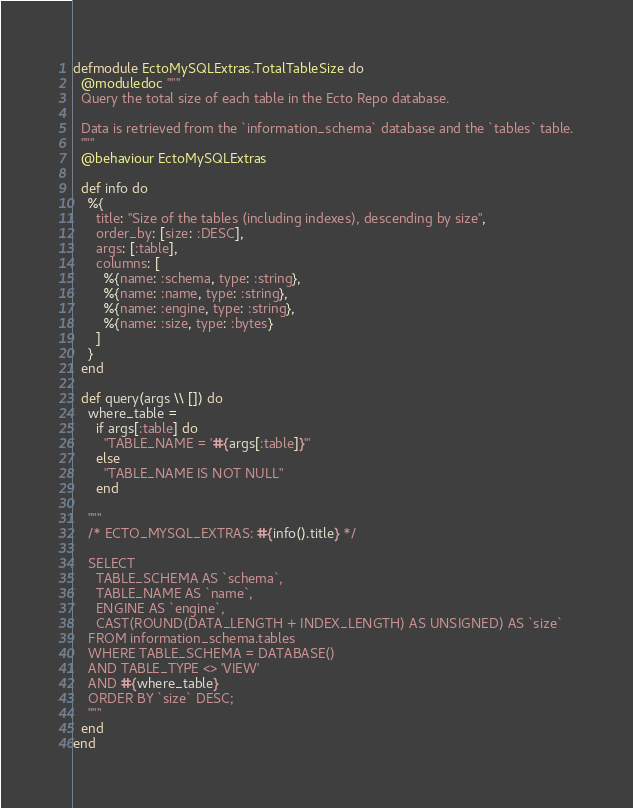<code> <loc_0><loc_0><loc_500><loc_500><_Elixir_>defmodule EctoMySQLExtras.TotalTableSize do
  @moduledoc """
  Query the total size of each table in the Ecto Repo database.

  Data is retrieved from the `information_schema` database and the `tables` table.
  """
  @behaviour EctoMySQLExtras

  def info do
    %{
      title: "Size of the tables (including indexes), descending by size",
      order_by: [size: :DESC],
      args: [:table],
      columns: [
        %{name: :schema, type: :string},
        %{name: :name, type: :string},
        %{name: :engine, type: :string},
        %{name: :size, type: :bytes}
      ]
    }
  end

  def query(args \\ []) do
    where_table =
      if args[:table] do
        "TABLE_NAME = '#{args[:table]}'"
      else
        "TABLE_NAME IS NOT NULL"
      end

    """
    /* ECTO_MYSQL_EXTRAS: #{info().title} */

    SELECT
      TABLE_SCHEMA AS `schema`,
      TABLE_NAME AS `name`,
      ENGINE AS `engine`,
      CAST(ROUND(DATA_LENGTH + INDEX_LENGTH) AS UNSIGNED) AS `size`
    FROM information_schema.tables
    WHERE TABLE_SCHEMA = DATABASE()
    AND TABLE_TYPE <> 'VIEW'
    AND #{where_table}
    ORDER BY `size` DESC;
    """
  end
end
</code> 